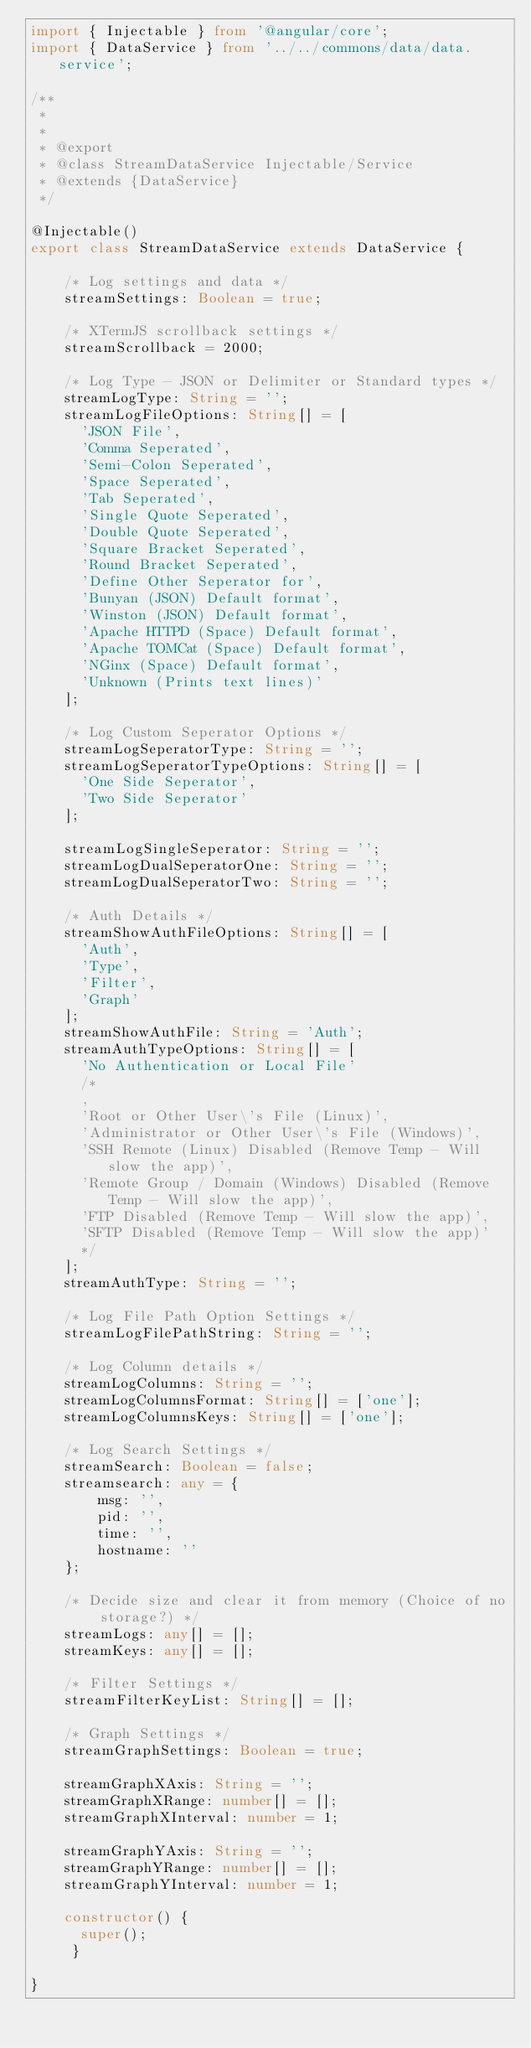Convert code to text. <code><loc_0><loc_0><loc_500><loc_500><_TypeScript_>import { Injectable } from '@angular/core';
import { DataService } from '../../commons/data/data.service';

/**
 * 
 * 
 * @export
 * @class StreamDataService Injectable/Service
 * @extends {DataService}
 */

@Injectable()
export class StreamDataService extends DataService {

    /* Log settings and data */
    streamSettings: Boolean = true;

    /* XTermJS scrollback settings */
    streamScrollback = 2000;

    /* Log Type - JSON or Delimiter or Standard types */
    streamLogType: String = '';
    streamLogFileOptions: String[] = [
      'JSON File',
      'Comma Seperated',
      'Semi-Colon Seperated',
      'Space Seperated',
      'Tab Seperated',
      'Single Quote Seperated',
      'Double Quote Seperated',
      'Square Bracket Seperated',
      'Round Bracket Seperated',
      'Define Other Seperator for', 
      'Bunyan (JSON) Default format',
      'Winston (JSON) Default format',
      'Apache HTTPD (Space) Default format',
      'Apache TOMCat (Space) Default format',
      'NGinx (Space) Default format',
      'Unknown (Prints text lines)'
    ];

    /* Log Custom Seperator Options */
    streamLogSeperatorType: String = '';
    streamLogSeperatorTypeOptions: String[] = [
      'One Side Seperator',
      'Two Side Seperator'
    ];

    streamLogSingleSeperator: String = '';
    streamLogDualSeperatorOne: String = '';
    streamLogDualSeperatorTwo: String = '';

    /* Auth Details */
    streamShowAuthFileOptions: String[] = [
      'Auth',
      'Type',
      'Filter',
      'Graph'
    ];
    streamShowAuthFile: String = 'Auth';
    streamAuthTypeOptions: String[] = [
      'No Authentication or Local File'
      /*
      ,
      'Root or Other User\'s File (Linux)',
      'Administrator or Other User\'s File (Windows)',
      'SSH Remote (Linux) Disabled (Remove Temp - Will slow the app)',
      'Remote Group / Domain (Windows) Disabled (Remove Temp - Will slow the app)',
      'FTP Disabled (Remove Temp - Will slow the app)',
      'SFTP Disabled (Remove Temp - Will slow the app)'
      */
    ];
    streamAuthType: String = '';
    
    /* Log File Path Option Settings */
    streamLogFilePathString: String = '';

    /* Log Column details */
    streamLogColumns: String = '';
    streamLogColumnsFormat: String[] = ['one'];
    streamLogColumnsKeys: String[] = ['one'];

    /* Log Search Settings */
    streamSearch: Boolean = false;
    streamsearch: any = {
        msg: '',
        pid: '',
        time: '',
        hostname: ''
    };

    /* Decide size and clear it from memory (Choice of no storage?) */
    streamLogs: any[] = [];
    streamKeys: any[] = [];
    
    /* Filter Settings */
    streamFilterKeyList: String[] = [];

    /* Graph Settings */
    streamGraphSettings: Boolean = true;

    streamGraphXAxis: String = '';
    streamGraphXRange: number[] = [];
    streamGraphXInterval: number = 1;

    streamGraphYAxis: String = '';
    streamGraphYRange: number[] = [];
    streamGraphYInterval: number = 1;

    constructor() {
      super();
     }

}
</code> 